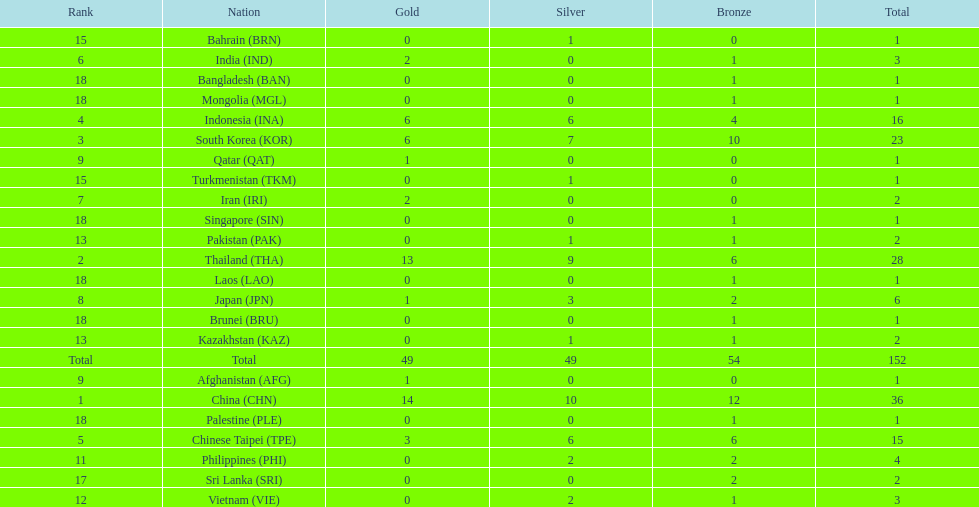How many nations received a medal in each gold, silver, and bronze? 6. 